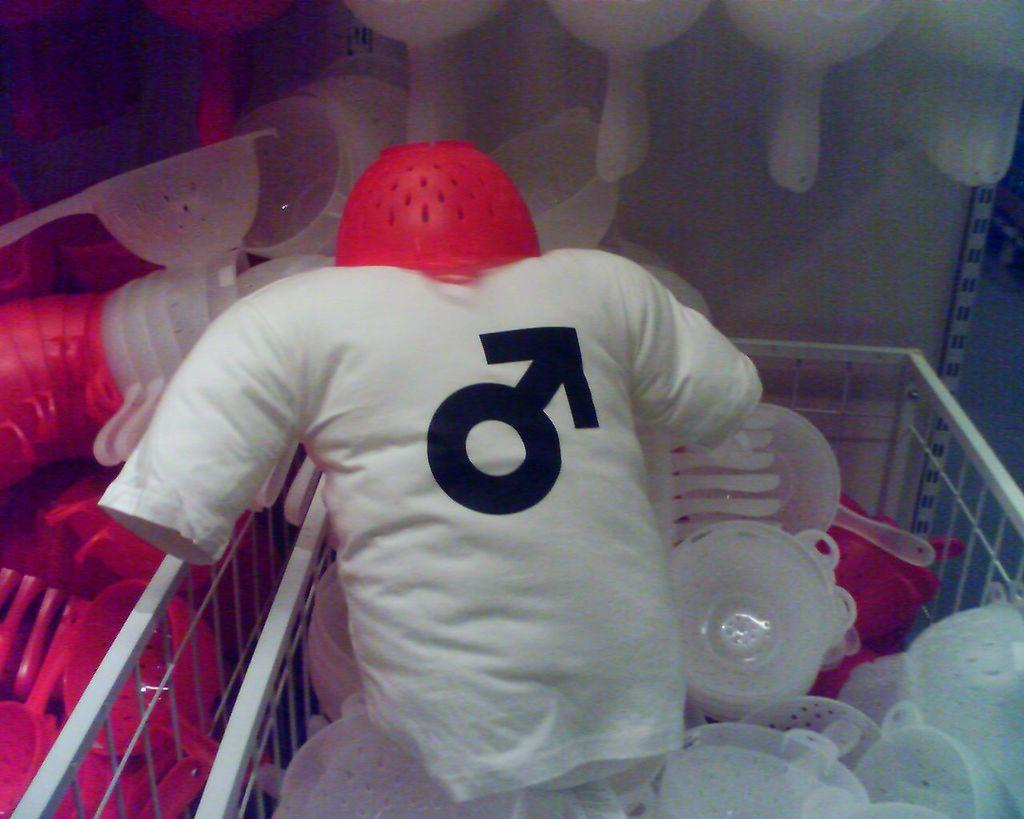What type of clothing item is visible in the image? There is a t-shirt in the image. What other items can be seen in the image? There are plastic containers visible in the image. How are the t-shirt and plastic containers organized in the image? The t-shirt and plastic containers are in baskets. Reasoning: Let' Let's think step by step in order to produce the conversation. We start by identifying the main subjects in the image, which are the t-shirt and plastic containers. Then, we describe how these items are organized, which is in baskets. Each question is designed to elicit a specific detail about the image that is known from the provided facts. Absurd Question/Answer: How many rings are visible on the t-shirt in the image? There are no rings visible on the t-shirt in the image. What sound can be heard coming from the plastic containers in the image? There is no sound coming from the plastic containers in the image. 